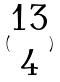Convert formula to latex. <formula><loc_0><loc_0><loc_500><loc_500>( \begin{matrix} 1 3 \\ 4 \end{matrix} )</formula> 